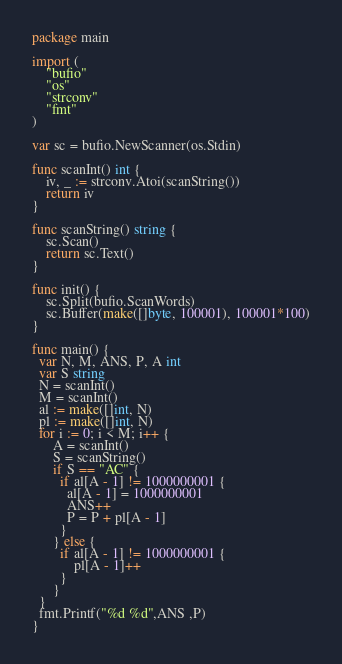Convert code to text. <code><loc_0><loc_0><loc_500><loc_500><_Go_>package main
 
import (
	"bufio"
	"os"
	"strconv"
	"fmt"
)
 
var sc = bufio.NewScanner(os.Stdin)
 
func scanInt() int {
	iv, _ := strconv.Atoi(scanString())
	return iv
}
 
func scanString() string {
	sc.Scan()
	return sc.Text()
}
 
func init() {
	sc.Split(bufio.ScanWords)
	sc.Buffer(make([]byte, 100001), 100001*100)
}

func main() {
  var N, M, ANS, P, A int
  var S string
  N = scanInt()
  M = scanInt()
  al := make([]int, N)
  pl := make([]int, N)
  for i := 0; i < M; i++ {
	  A = scanInt()
	  S = scanString()
      if S == "AC" {
		if al[A - 1] != 1000000001 {
		  al[A - 1] = 1000000001
		  ANS++
		  P = P + pl[A - 1]
		}
	  } else {
		if al[A - 1] != 1000000001 {
			pl[A - 1]++
		}
	  }
  }
  fmt.Printf("%d %d",ANS ,P)
}</code> 